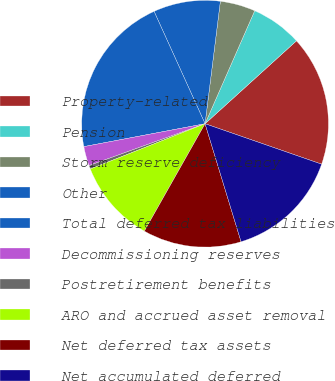Convert chart to OTSL. <chart><loc_0><loc_0><loc_500><loc_500><pie_chart><fcel>Property-related<fcel>Pension<fcel>Storm reserve deficiency<fcel>Other<fcel>Total deferred tax liabilities<fcel>Decommissioning reserves<fcel>Postretirement benefits<fcel>ARO and accrued asset removal<fcel>Net deferred tax assets<fcel>Net accumulated deferred<nl><fcel>17.04%<fcel>6.69%<fcel>4.61%<fcel>8.76%<fcel>21.19%<fcel>2.54%<fcel>0.47%<fcel>10.83%<fcel>12.9%<fcel>14.97%<nl></chart> 